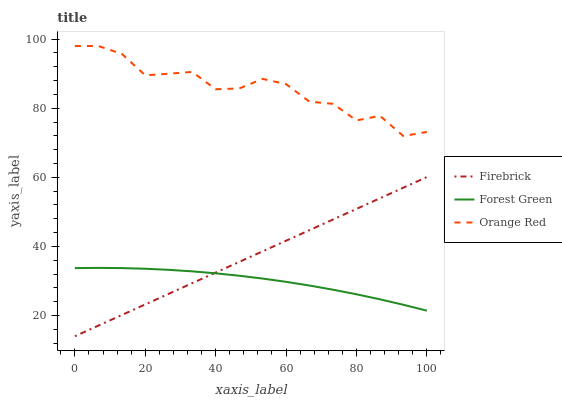Does Forest Green have the minimum area under the curve?
Answer yes or no. Yes. Does Orange Red have the maximum area under the curve?
Answer yes or no. Yes. Does Orange Red have the minimum area under the curve?
Answer yes or no. No. Does Forest Green have the maximum area under the curve?
Answer yes or no. No. Is Firebrick the smoothest?
Answer yes or no. Yes. Is Orange Red the roughest?
Answer yes or no. Yes. Is Forest Green the smoothest?
Answer yes or no. No. Is Forest Green the roughest?
Answer yes or no. No. Does Firebrick have the lowest value?
Answer yes or no. Yes. Does Forest Green have the lowest value?
Answer yes or no. No. Does Orange Red have the highest value?
Answer yes or no. Yes. Does Forest Green have the highest value?
Answer yes or no. No. Is Firebrick less than Orange Red?
Answer yes or no. Yes. Is Orange Red greater than Firebrick?
Answer yes or no. Yes. Does Firebrick intersect Forest Green?
Answer yes or no. Yes. Is Firebrick less than Forest Green?
Answer yes or no. No. Is Firebrick greater than Forest Green?
Answer yes or no. No. Does Firebrick intersect Orange Red?
Answer yes or no. No. 